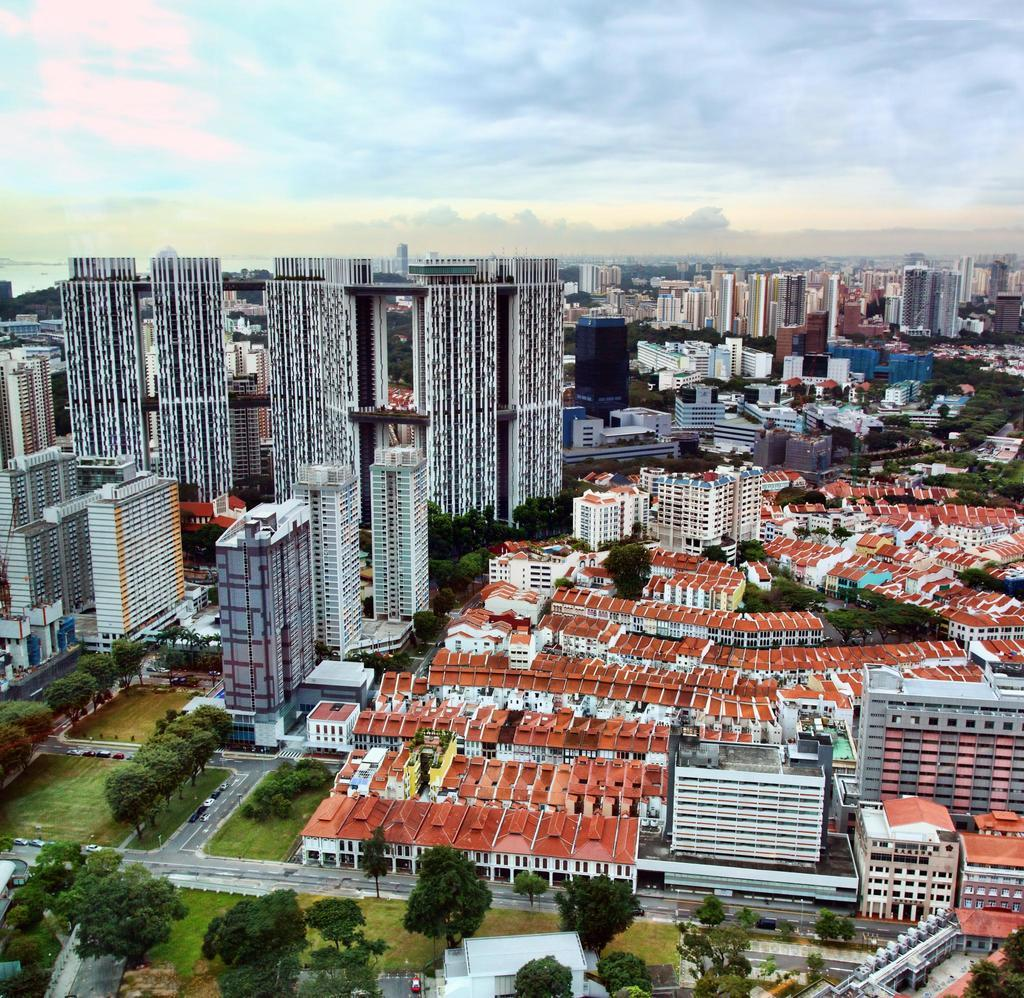What types of structures can be seen in the image? There are multiple buildings in the image. What other natural elements are present in the image? There are trees and green grass visible in the image. What is visible in the background of the image? The sky is visible in the background of the image. How would you describe the sky in the image? The sky appears to be slightly cloudy. How many sisters are sitting on the grass in the image? There are no sisters present in the image; it features multiple buildings, trees, grass, and a slightly cloudy sky. 